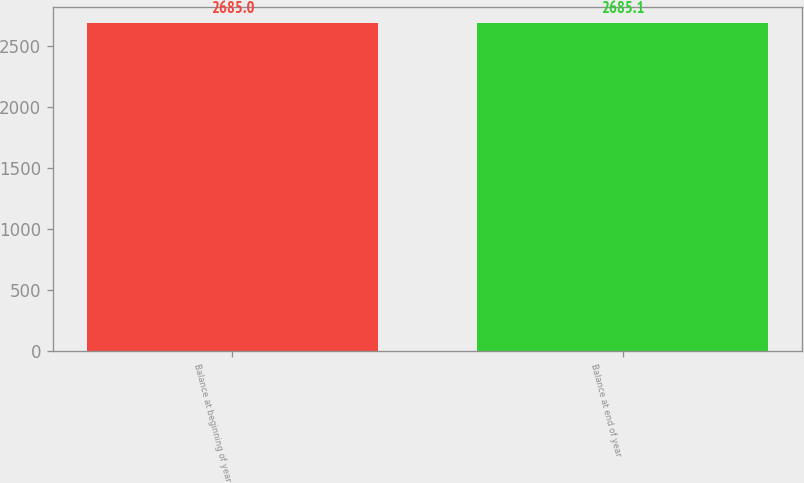Convert chart to OTSL. <chart><loc_0><loc_0><loc_500><loc_500><bar_chart><fcel>Balance at beginning of year<fcel>Balance at end of year<nl><fcel>2685<fcel>2685.1<nl></chart> 